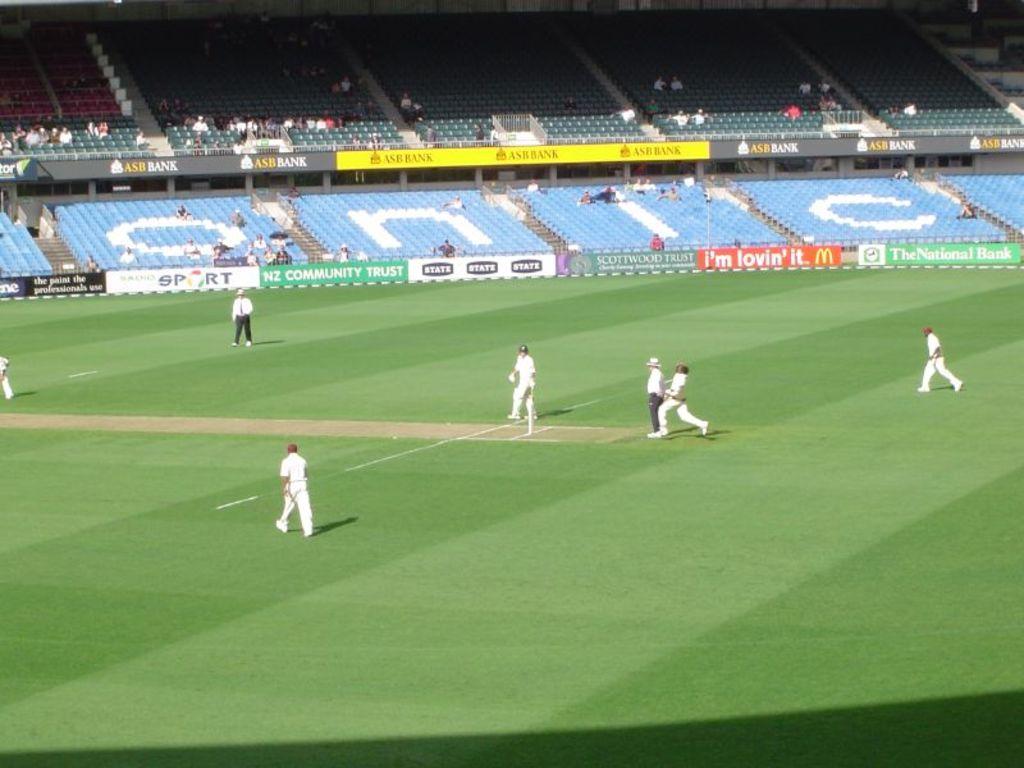Which company is advertised on the banner on the far right?
Your answer should be compact. The national bank. What letters are shown on the blue background?
Your response must be concise. Onic. 